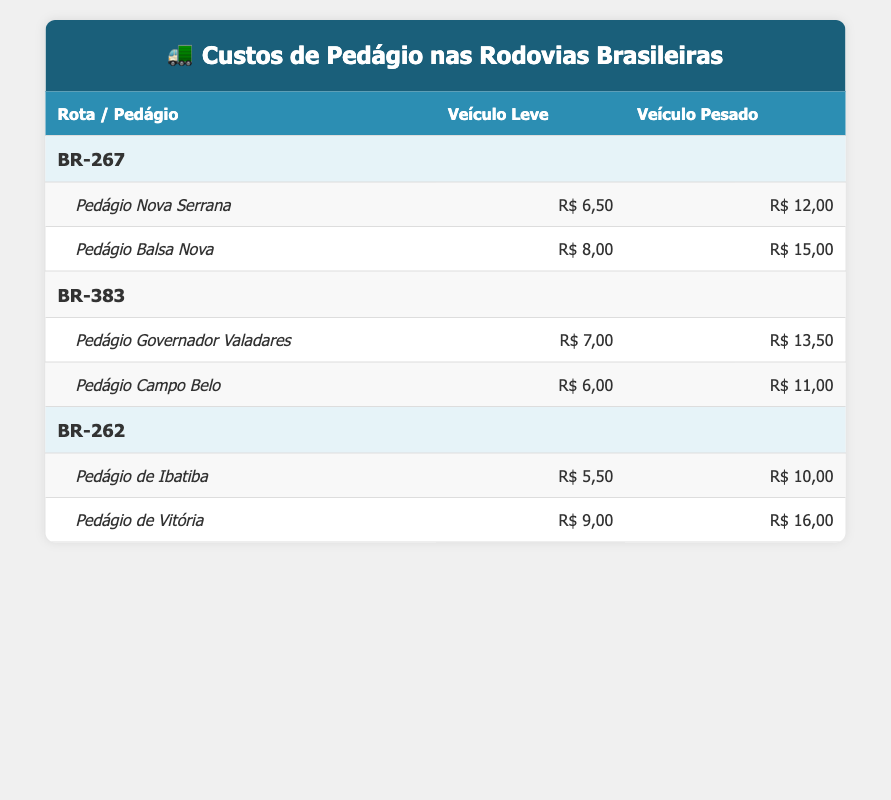What is the cost of using the Pedágio Nova Serrana for a heavy vehicle? The table lists the cost for the Pedágio Nova Serrana under the BR-267 route. The cost for a heavy vehicle is stated directly in the table as R$ 12,00.
Answer: R$ 12,00 Which toll costs the most for light vehicles on the BR-267 route? Under the BR-267 route, we compare the tolls: Pedágio Nova Serrana costs R$ 6,50 and Pedágio Balsa Nova costs R$ 8,00. The highest cost for light vehicles is R$ 8,00 at the Pedágio Balsa Nova.
Answer: R$ 8,00 Is the total cost for using the BR-383 for heavy vehicles greater than R$ 25,00? Adding the costs for heavy vehicles on the BR-383 route: Pedágio Governador Valadares costs R$ 13,50, and Pedágio Campo Belo costs R$ 11,00. The total is R$ 13,50 + R$ 11,00 = R$ 24,50, which is less than R$ 25,00.
Answer: No What is the average cost for heavy vehicles across all routes? We calculate the average by taking the total costs of heavy vehicles: BR-267 total = R$ 12,00 + R$ 15,00 = R$ 27,00; BR-383 total = R$ 13,50 + R$ 11,00 = R$ 24,50; BR-262 total = R$ 10,00 + R$ 16,00 = R$ 26,00. Summing these gives R$ 27,00 + R$ 24,50 + R$ 26,00 = R$ 77,50, and dividing by the number of tolls (6) gives an average of R$ 12,92.
Answer: R$ 12,92 Which route has the lowest total toll cost for heavy vehicles? We first calculate the total cost for heavy vehicles on each route: BR-267 = R$ 12,00 + R$ 15,00 = R$ 27,00; BR-383 = R$ 13,50 + R$ 11,00 = R$ 24,50; BR-262 = R$ 10,00 + R$ 16,00 = R$ 26,00. The lowest total is R$ 24,50 on the BR-383 route.
Answer: BR-383 